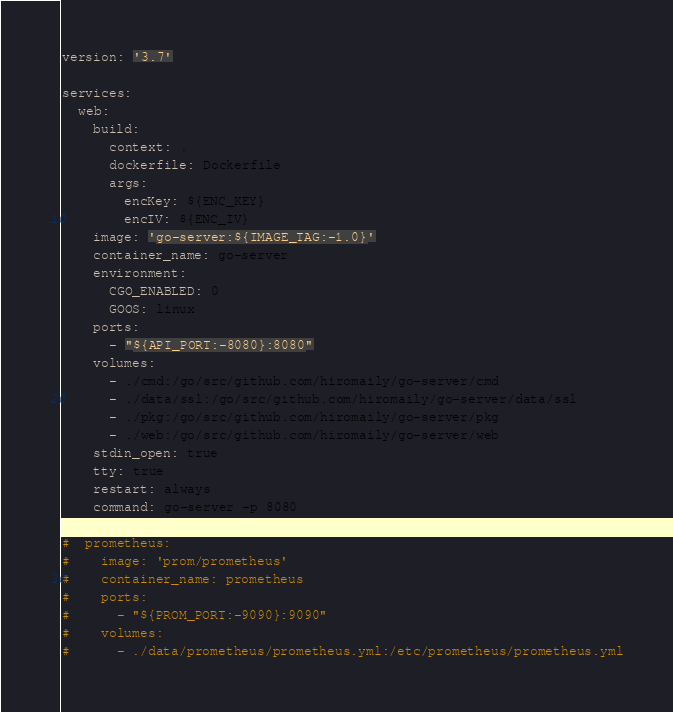Convert code to text. <code><loc_0><loc_0><loc_500><loc_500><_YAML_>version: '3.7'

services:
  web:
    build:
      context: .
      dockerfile: Dockerfile
      args:
        encKey: ${ENC_KEY}
        encIV: ${ENC_IV}
    image: 'go-server:${IMAGE_TAG:-1.0}'
    container_name: go-server
    environment:
      CGO_ENABLED: 0
      GOOS: linux
    ports:
      - "${API_PORT:-8080}:8080"
    volumes:
      - ./cmd:/go/src/github.com/hiromaily/go-server/cmd
      - ./data/ssl:/go/src/github.com/hiromaily/go-server/data/ssl
      - ./pkg:/go/src/github.com/hiromaily/go-server/pkg
      - ./web:/go/src/github.com/hiromaily/go-server/web
    stdin_open: true
    tty: true
    restart: always
    command: go-server -p 8080

#  prometheus:
#    image: 'prom/prometheus'
#    container_name: prometheus
#    ports:
#      - "${PROM_PORT:-9090}:9090"
#    volumes:
#      - ./data/prometheus/prometheus.yml:/etc/prometheus/prometheus.yml
</code> 